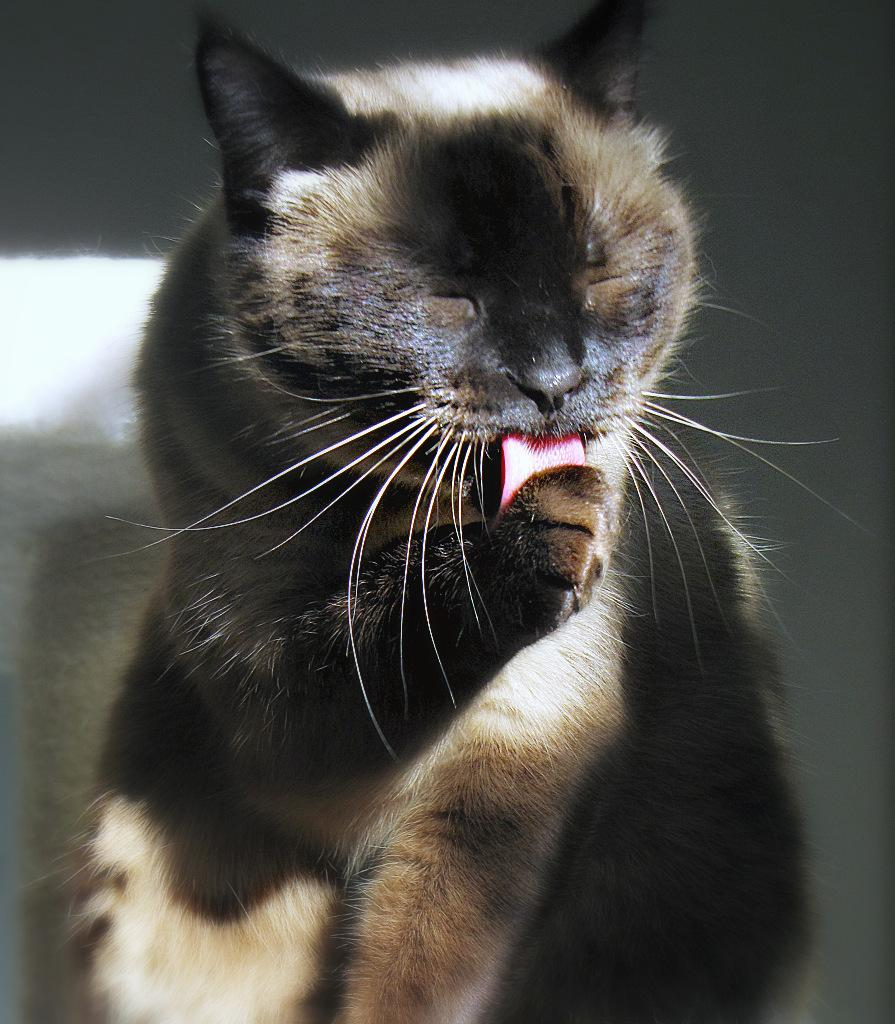What animal is in the foreground of the image? There is a cat in the foreground of the image. Can you describe the color of the cat? The cat is partially black and brown. What is the cat doing in the image? The cat is sitting and licking its leg. What type of scissors can be seen cutting the cat's fur in the image? There are no scissors present in the image, and the cat's fur is not being cut. 